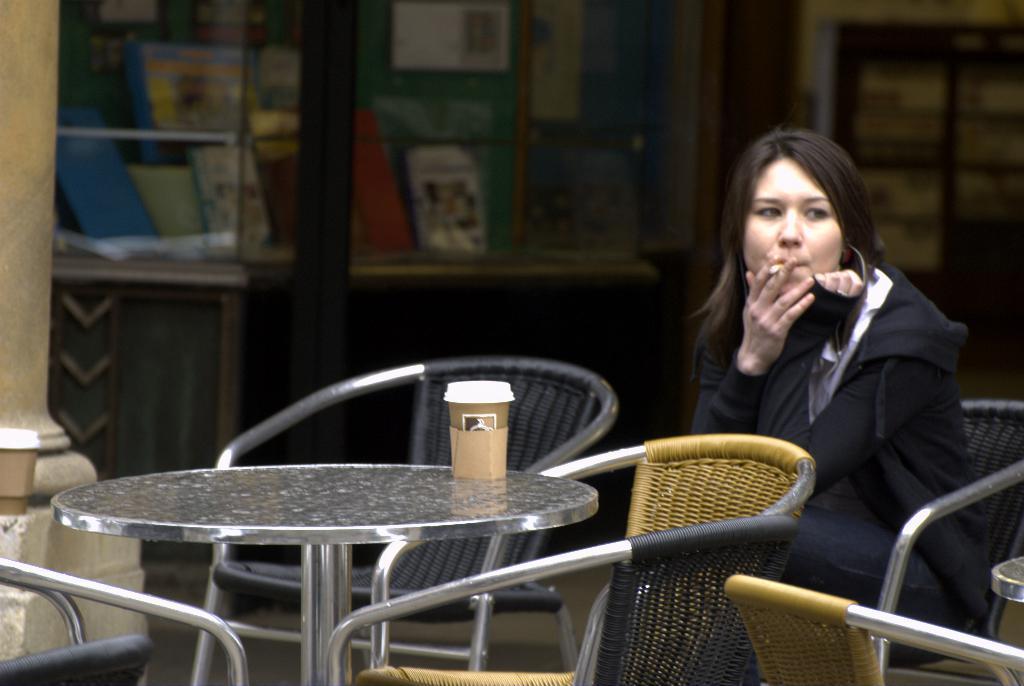Could you give a brief overview of what you see in this image? In this picture, there is a woman who is sitting on the chair and smoking. There is a cup which is placed on the table. There is a cupboard in which many books are kept. To the left side, there is a pillar. 